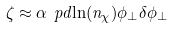<formula> <loc_0><loc_0><loc_500><loc_500>\zeta \approx \alpha \ p d { \ln ( n _ { \chi } ) } { \phi _ { \perp } } \delta \phi _ { \perp }</formula> 